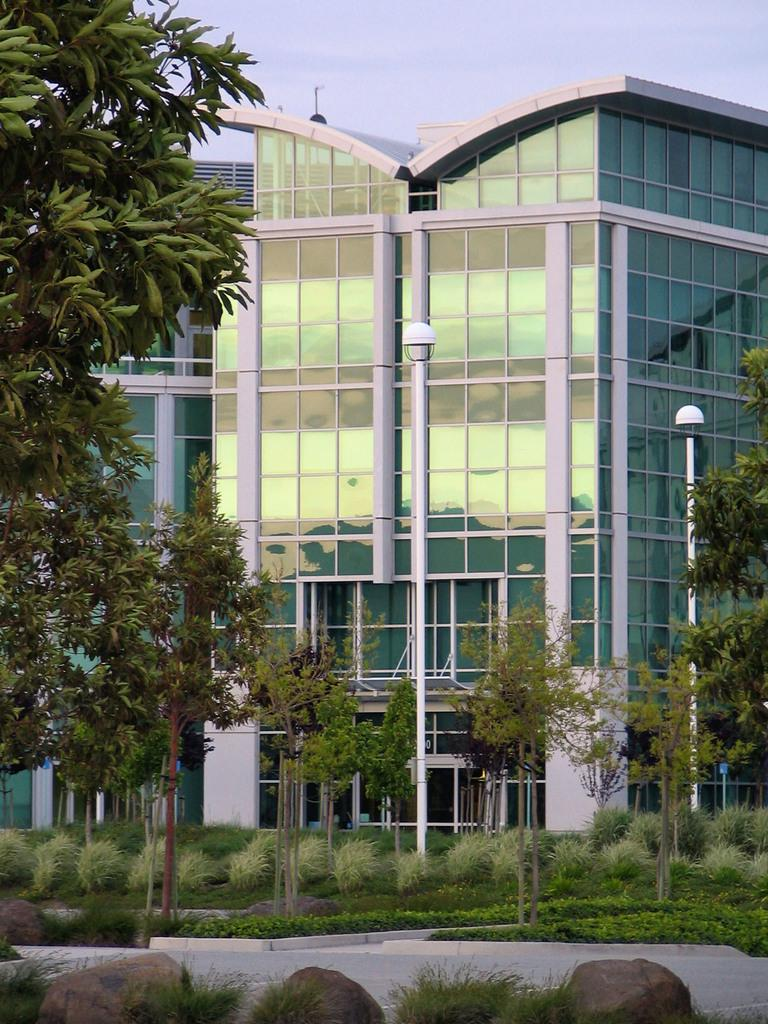What is the main subject of the image? The main subject of the image is a building. What can be seen in front of the building? There are trees, grass, and rocks in front of the building. What type of dress can be seen on the building in the image? There is no dress present on the building in the image. 